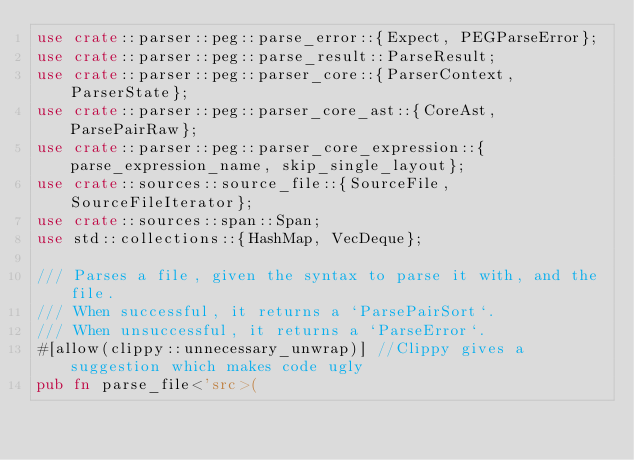<code> <loc_0><loc_0><loc_500><loc_500><_Rust_>use crate::parser::peg::parse_error::{Expect, PEGParseError};
use crate::parser::peg::parse_result::ParseResult;
use crate::parser::peg::parser_core::{ParserContext, ParserState};
use crate::parser::peg::parser_core_ast::{CoreAst, ParsePairRaw};
use crate::parser::peg::parser_core_expression::{parse_expression_name, skip_single_layout};
use crate::sources::source_file::{SourceFile, SourceFileIterator};
use crate::sources::span::Span;
use std::collections::{HashMap, VecDeque};

/// Parses a file, given the syntax to parse it with, and the file.
/// When successful, it returns a `ParsePairSort`.
/// When unsuccessful, it returns a `ParseError`.
#[allow(clippy::unnecessary_unwrap)] //Clippy gives a suggestion which makes code ugly
pub fn parse_file<'src>(</code> 